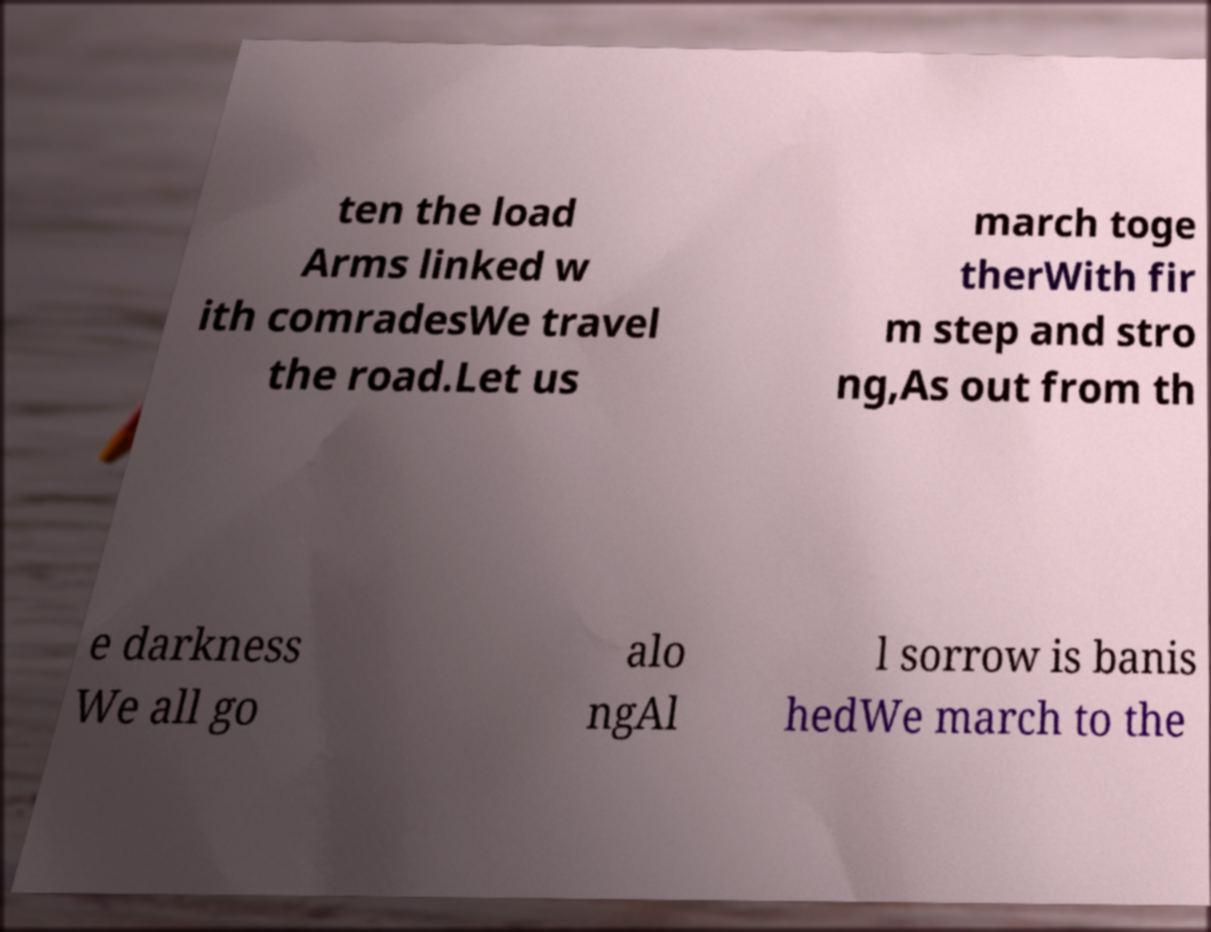Please identify and transcribe the text found in this image. ten the load Arms linked w ith comradesWe travel the road.Let us march toge therWith fir m step and stro ng,As out from th e darkness We all go alo ngAl l sorrow is banis hedWe march to the 